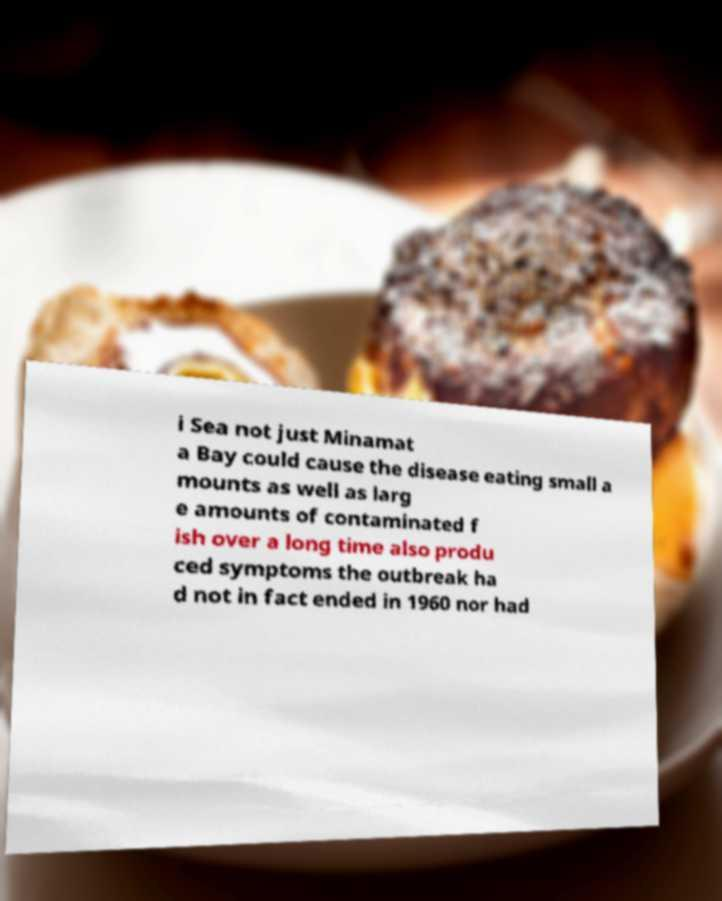Could you assist in decoding the text presented in this image and type it out clearly? i Sea not just Minamat a Bay could cause the disease eating small a mounts as well as larg e amounts of contaminated f ish over a long time also produ ced symptoms the outbreak ha d not in fact ended in 1960 nor had 